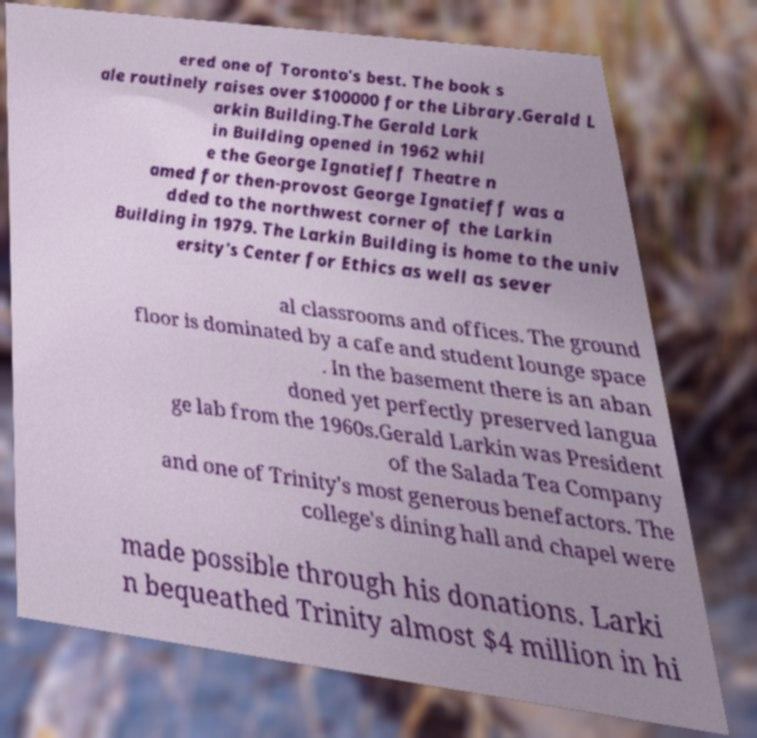What messages or text are displayed in this image? I need them in a readable, typed format. ered one of Toronto's best. The book s ale routinely raises over $100000 for the Library.Gerald L arkin Building.The Gerald Lark in Building opened in 1962 whil e the George Ignatieff Theatre n amed for then-provost George Ignatieff was a dded to the northwest corner of the Larkin Building in 1979. The Larkin Building is home to the univ ersity's Center for Ethics as well as sever al classrooms and offices. The ground floor is dominated by a cafe and student lounge space . In the basement there is an aban doned yet perfectly preserved langua ge lab from the 1960s.Gerald Larkin was President of the Salada Tea Company and one of Trinity's most generous benefactors. The college's dining hall and chapel were made possible through his donations. Larki n bequeathed Trinity almost $4 million in hi 